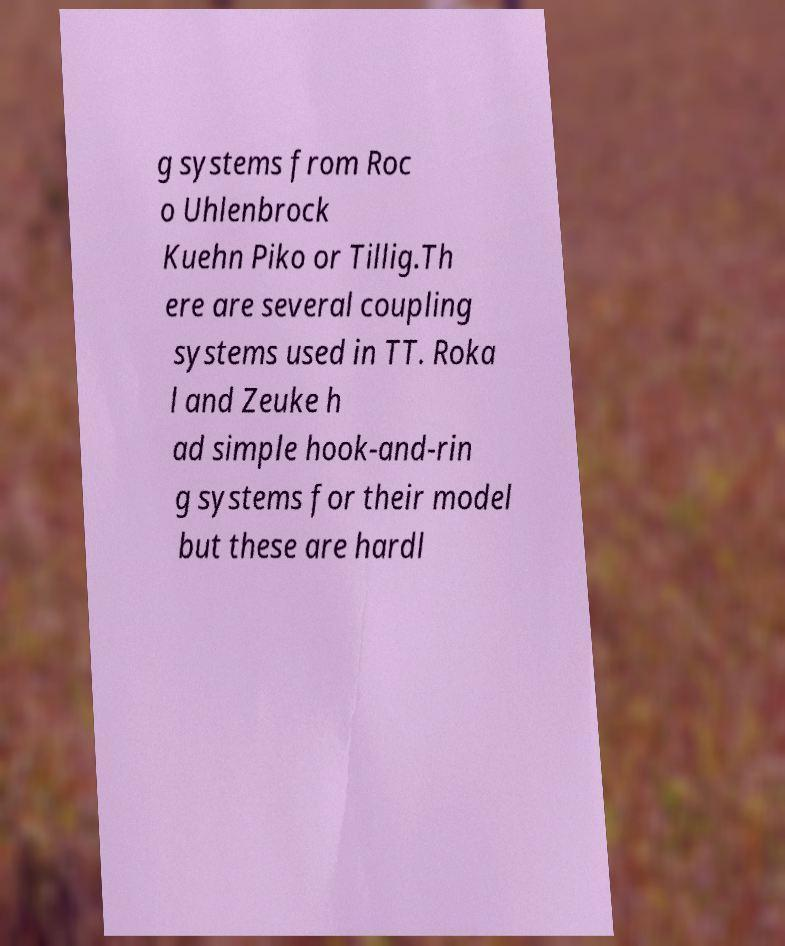Please identify and transcribe the text found in this image. g systems from Roc o Uhlenbrock Kuehn Piko or Tillig.Th ere are several coupling systems used in TT. Roka l and Zeuke h ad simple hook-and-rin g systems for their model but these are hardl 